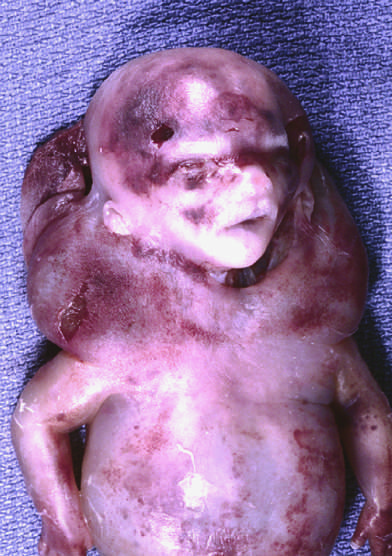what has been termed cystic hygroma?
Answer the question using a single word or phrase. Fluid accumulation particularly prominent in the soft tissues of the neck 